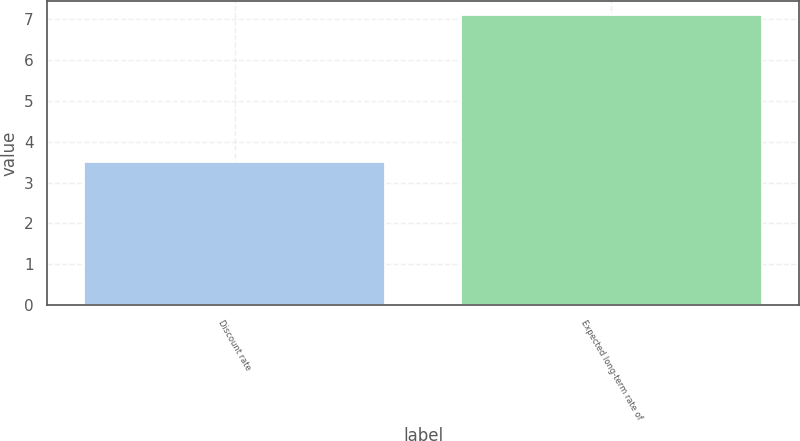<chart> <loc_0><loc_0><loc_500><loc_500><bar_chart><fcel>Discount rate<fcel>Expected long-term rate of<nl><fcel>3.5<fcel>7.1<nl></chart> 